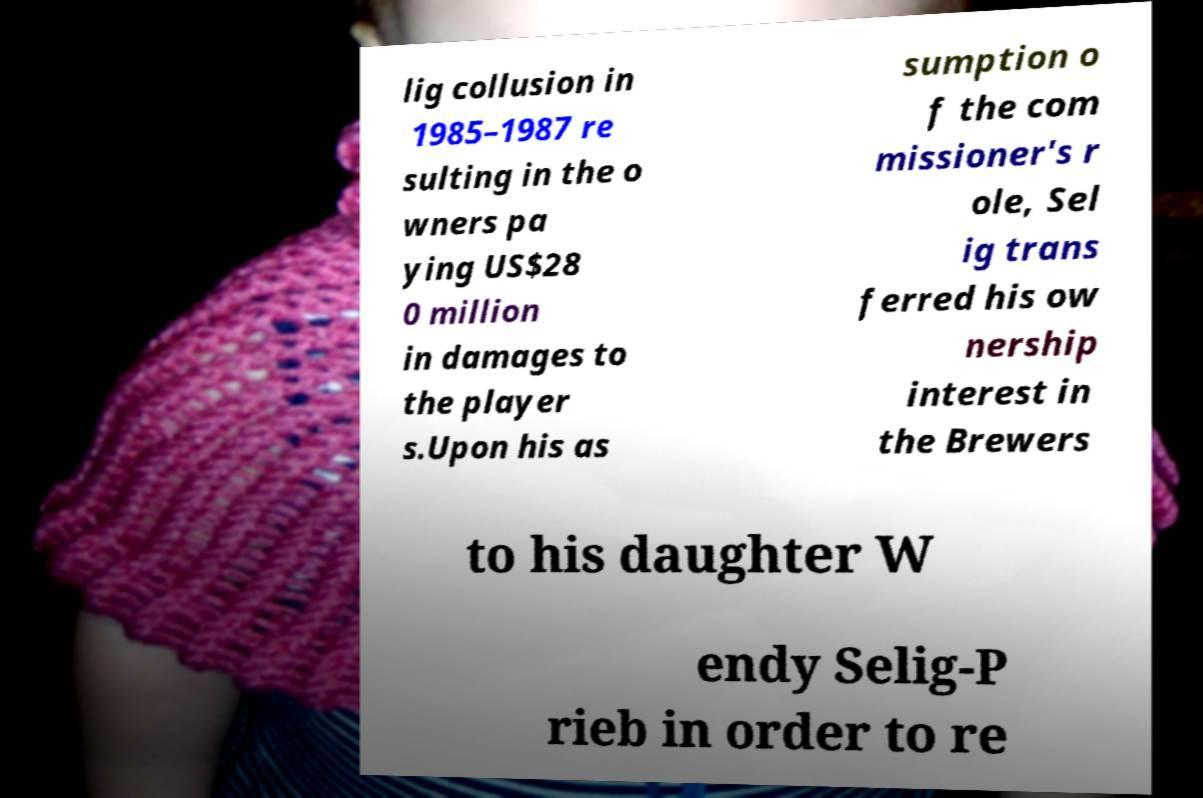For documentation purposes, I need the text within this image transcribed. Could you provide that? lig collusion in 1985–1987 re sulting in the o wners pa ying US$28 0 million in damages to the player s.Upon his as sumption o f the com missioner's r ole, Sel ig trans ferred his ow nership interest in the Brewers to his daughter W endy Selig-P rieb in order to re 